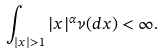<formula> <loc_0><loc_0><loc_500><loc_500>\int _ { | x | > 1 } | x | ^ { \alpha } \nu ( d x ) < \infty .</formula> 